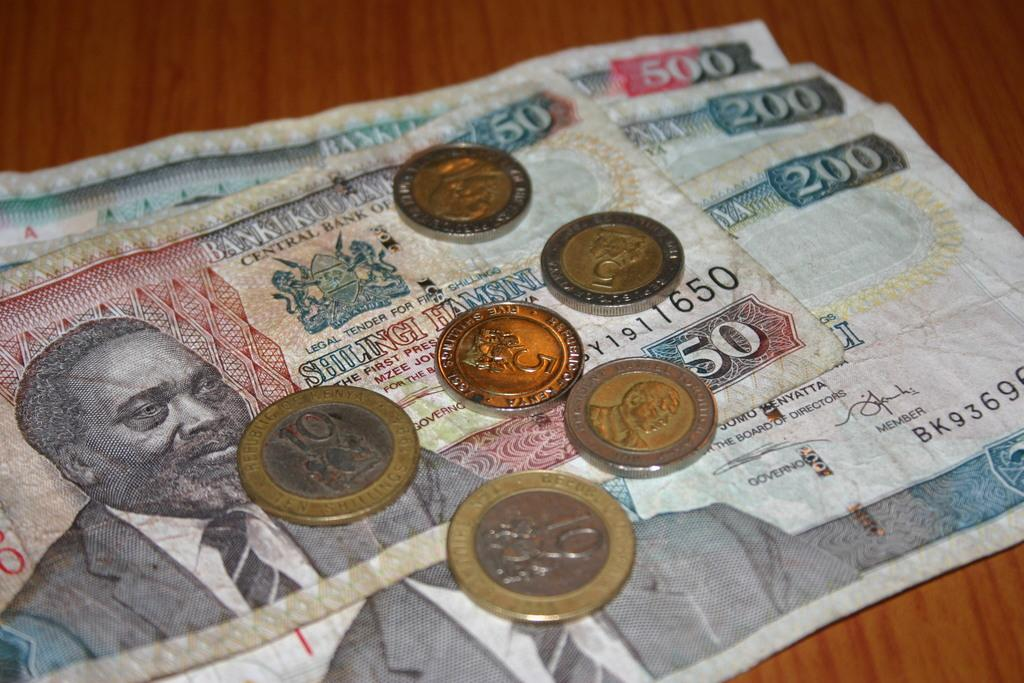<image>
Create a compact narrative representing the image presented. bills of money on top of bills of money with the number 50 on one of them 